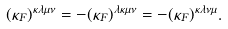<formula> <loc_0><loc_0><loc_500><loc_500>( \kappa _ { F } ) ^ { \kappa \lambda \mu \nu } = - ( \kappa _ { F } ) ^ { \lambda \kappa \mu \nu } = - ( \kappa _ { F } ) ^ { \kappa \lambda \nu \mu } .</formula> 